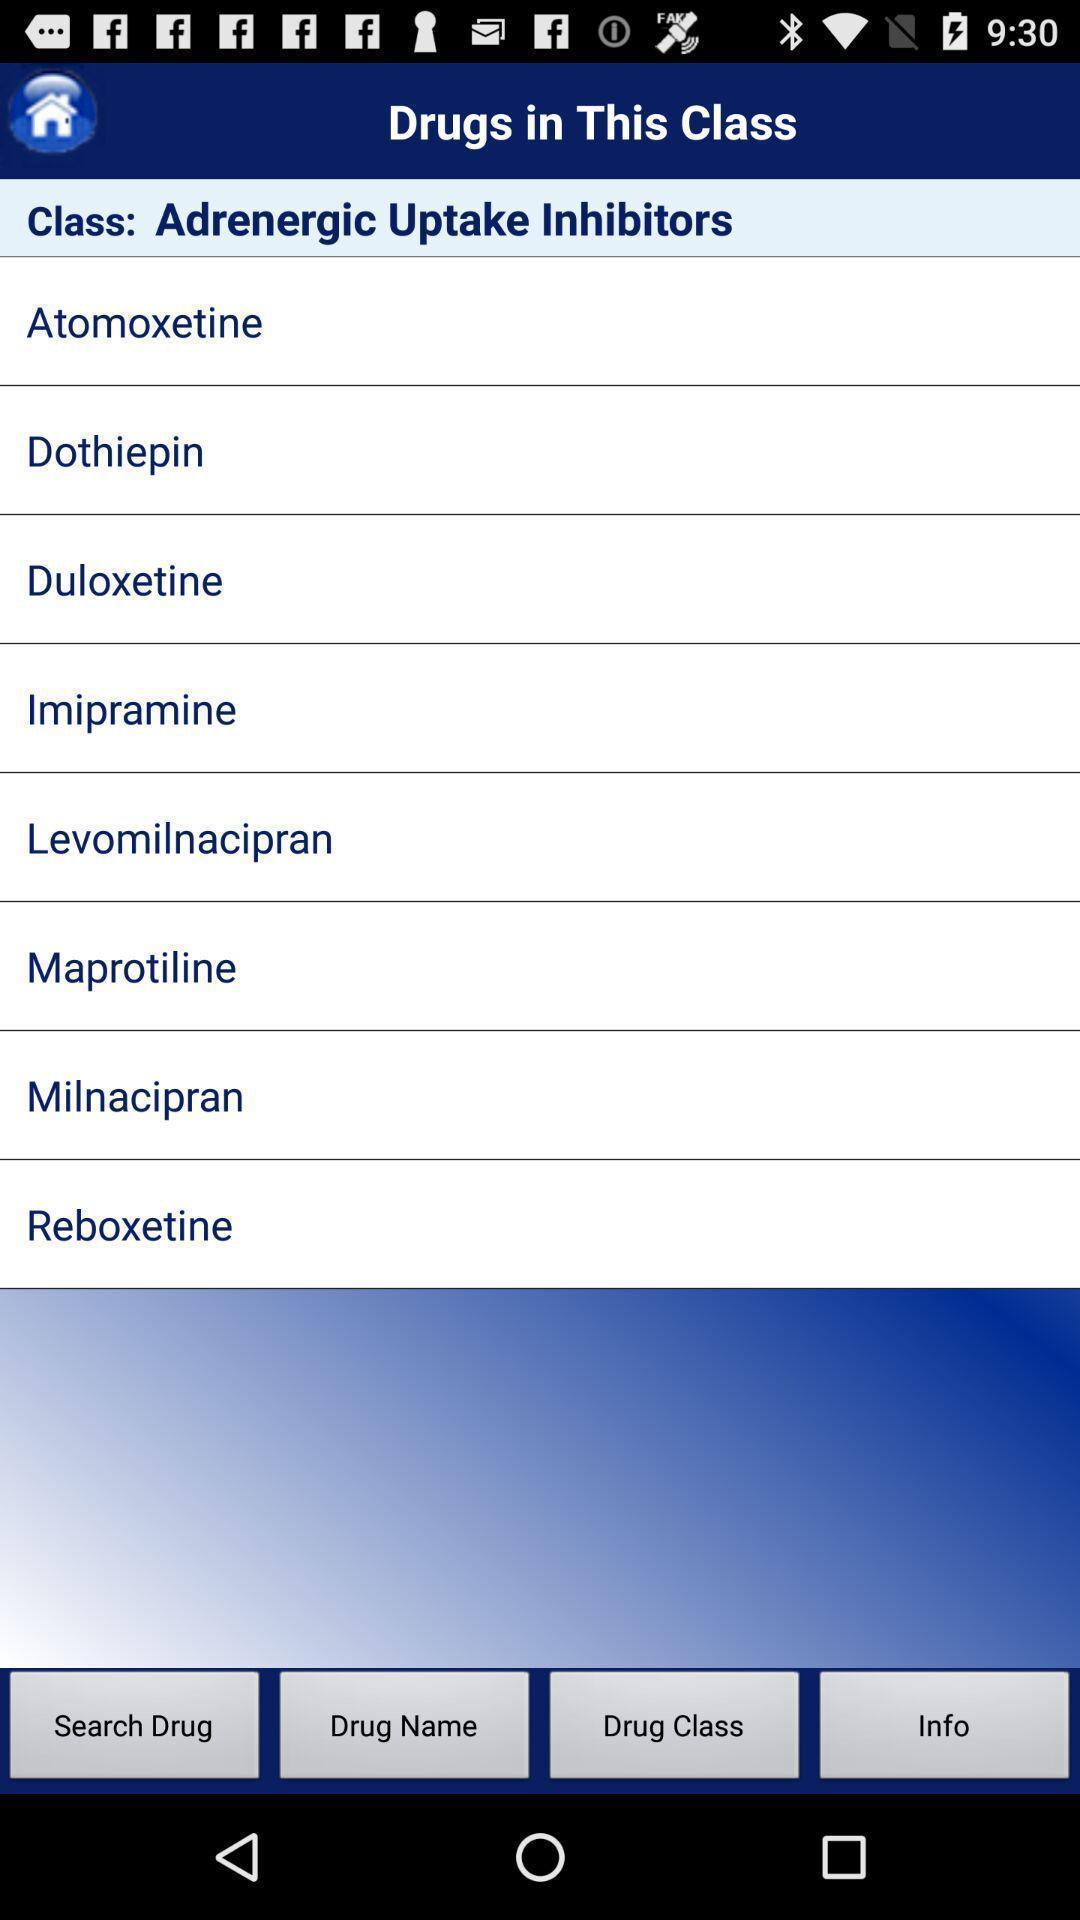Please provide a description for this image. Screen displaying class. 